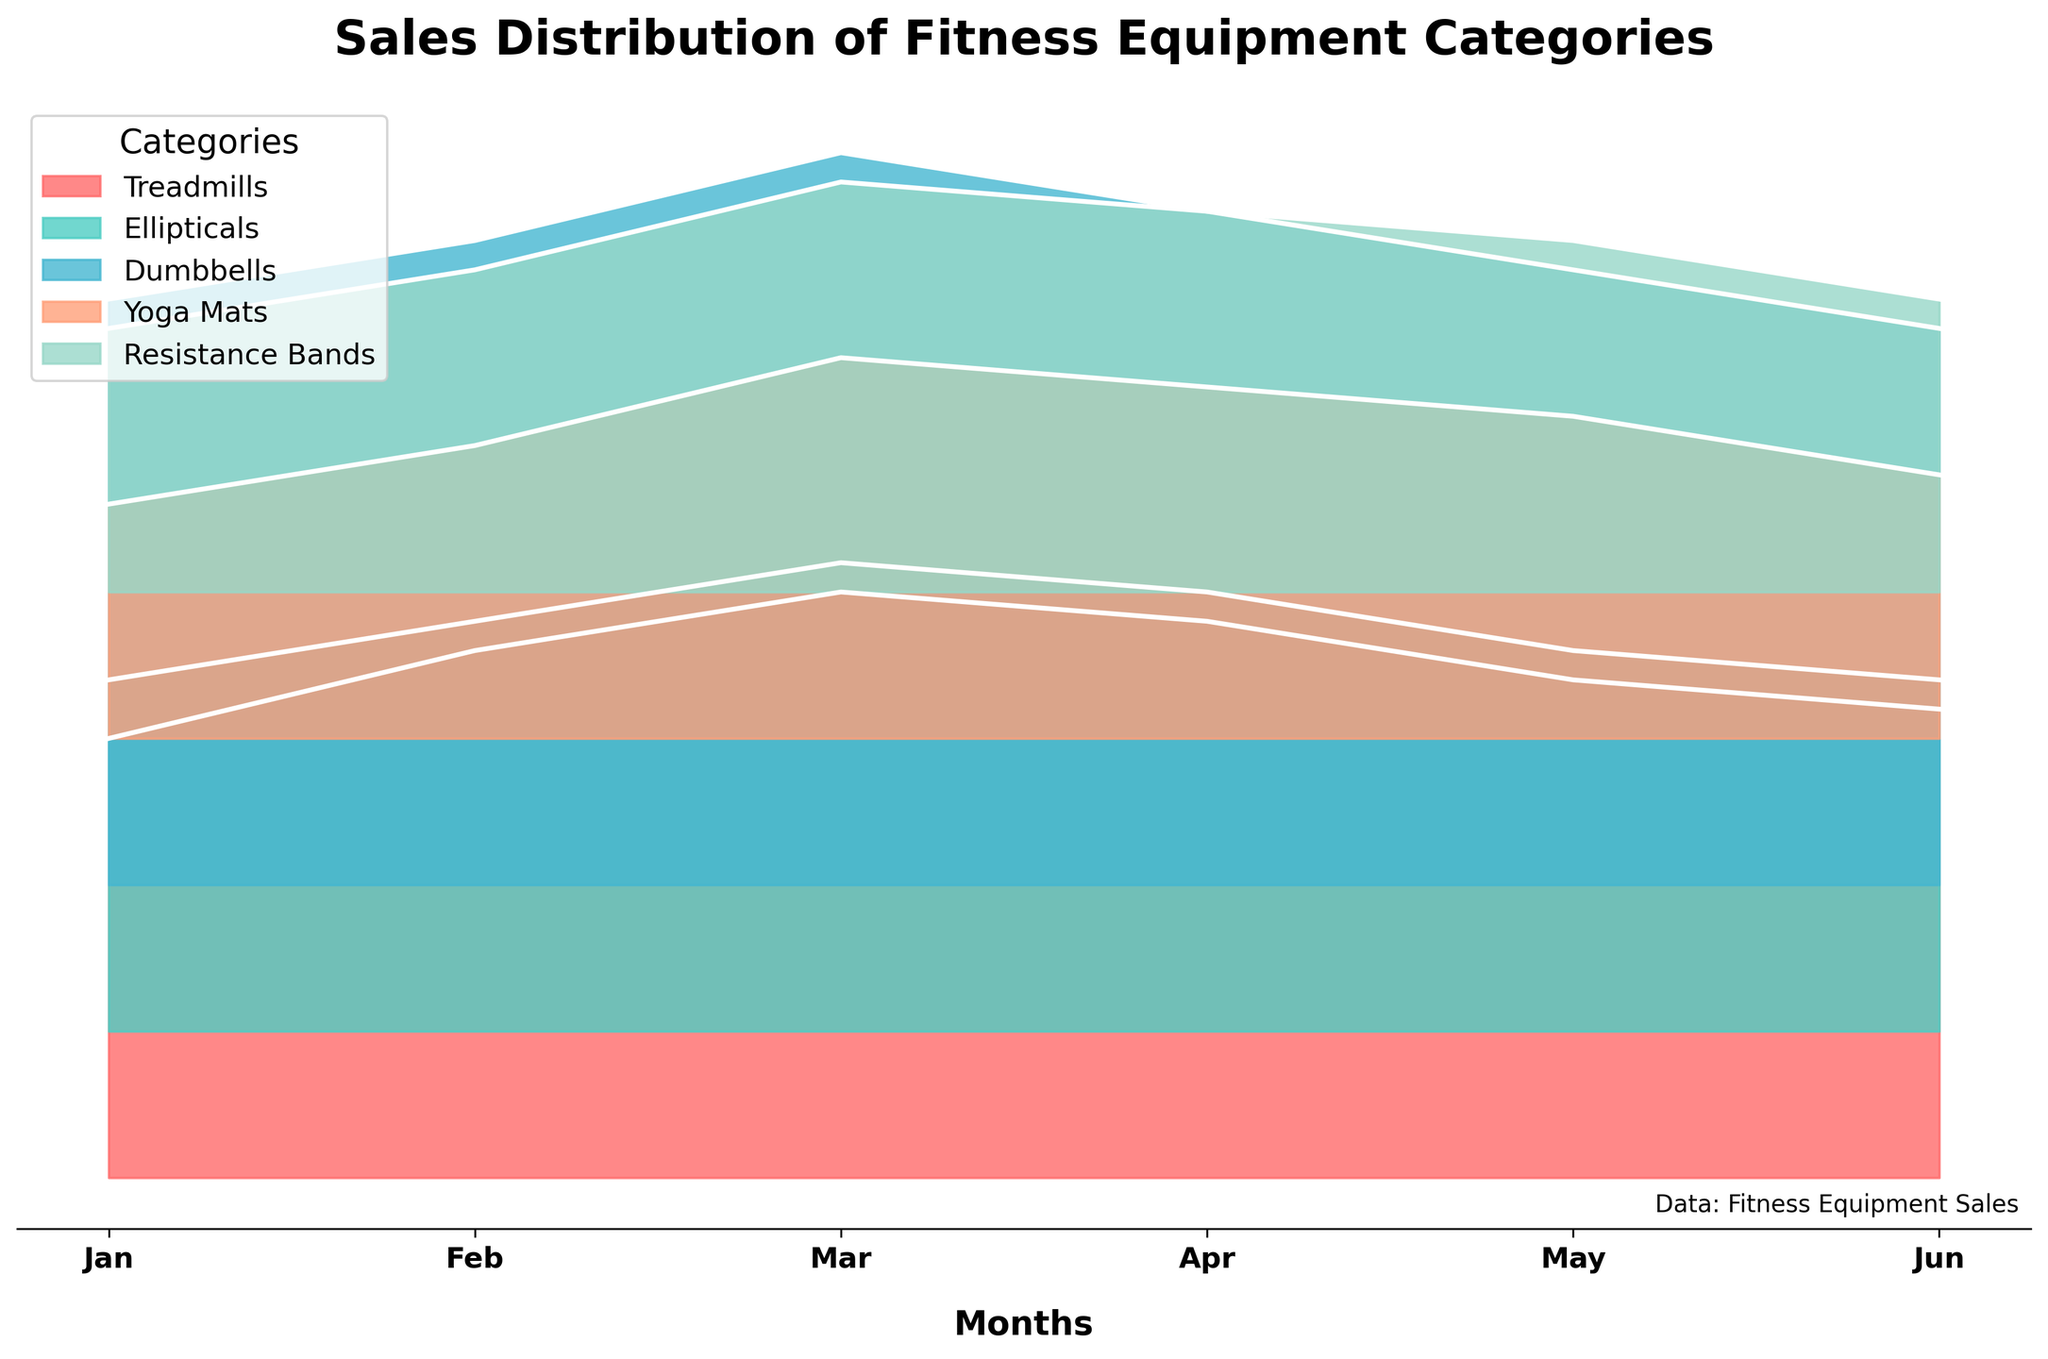What is the title of the plot? The title is displayed prominently at the top of the plot. It reads "Sales Distribution of Fitness Equipment Categories".
Answer: Sales Distribution of Fitness Equipment Categories Which month has the highest sales for Dumbbells? By looking at the plot, each category has a different color, and the higher the filled area within a month, the higher the sales. The category "Dumbbells" has the highest peak in March.
Answer: March Which category has the least sales in June? The smallest filled area in June can be identified based on the lowest height within that month. The category with the least sales is "Yoga Mats".
Answer: Yoga Mats How do Treadmill sales in January compare to those in June? By comparing the filled areas for Treadmills in January and June, January's area is higher than June's. Sales for Treadmills in January are 150, whereas in June they are 160. So, June's sales are actually higher.
Answer: June sales are higher What is the difference in sales between Yoga Mats in March and April? The sales for Yoga Mats in March are 130 and in April are 120. The difference can be calculated by subtracting April's sales from March's sales: 130 - 120.
Answer: 10 Which equipment category shows a consistent increase in sales from January to March? Checking the filled areas for each category from January to March, "Dumbbells" show a consistent increase each month.
Answer: Dumbbells What is the average sales for Ellipticals across all months? To calculate the average, sum the monthly sales for Ellipticals (120 + 140 + 160 + 150 + 130 + 120 = 820) and divide by the number of months (6). 820/6.
Answer: 136.67 Compare the sales trend of Resistance Bands from January to May. Is there any noticeable pattern? Observing the filled areas for Resistance Bands from January to May, the sales show a steady increase until March and then a slight decrease until June.
Answer: Increase till March, then decrease What are the highest sales recorded for any category, and in which month does it happen? Looking at all categories across all months, the highest filled area is for Dumbbells in March, which records sales of 250.
Answer: 250 in March Describe the color-coding in the plot. The different categories are represented by different colors: Treadmills, Ellipticals, Dumbbells, Yoga Mats, and Resistance Bands. These colors vary but are distinct and easily distinguishable.
Answer: Different colors represent different categories 